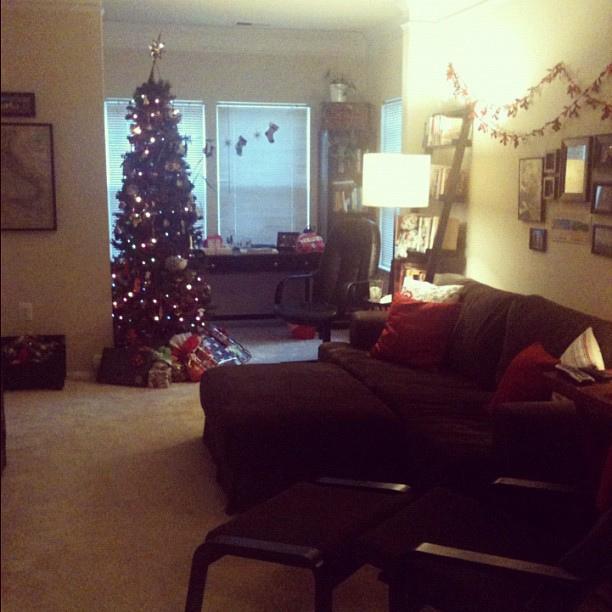How many laps do you see?
Answer briefly. 0. Where are the Christmas stockings?
Short answer required. Wall. What holiday is being observed?
Be succinct. Christmas. What color is the carpet?
Write a very short answer. Beige. How many windows are there?
Be succinct. 3. How many lights are in the Christmas tree?
Be succinct. 100. Is the Christmas tree decorated nicely?
Quick response, please. Yes. 